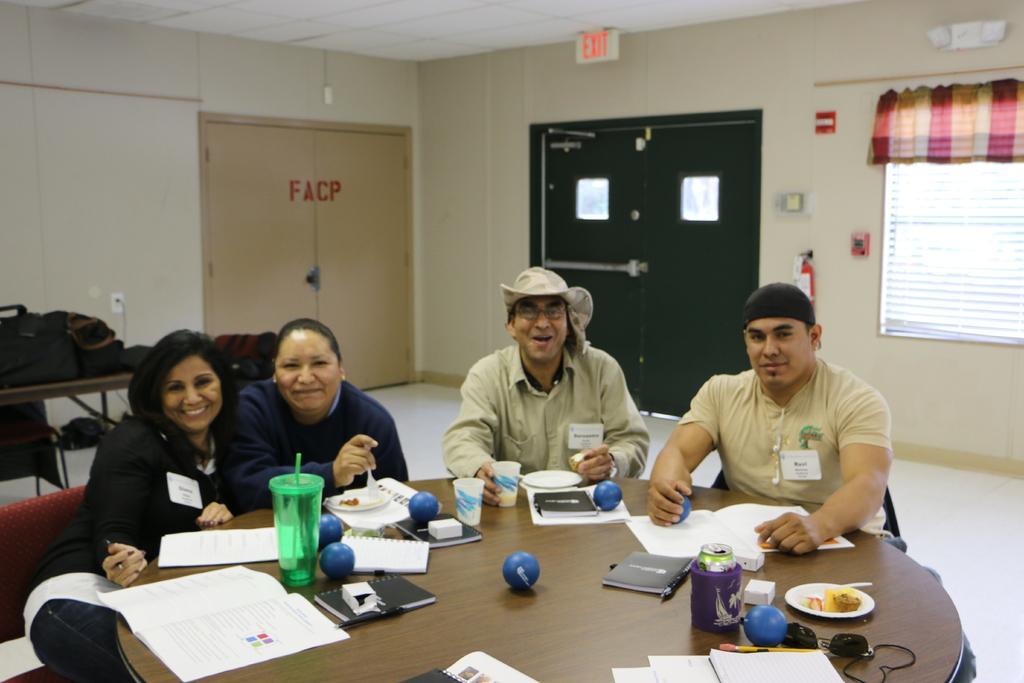Can you describe this image briefly? This picture is inside the room. There are group of people sitting around the table. There are books, pens, cups, paper, plates on the table. At the back there are doors, at the right there is a window and at the left there are bags on the table. 